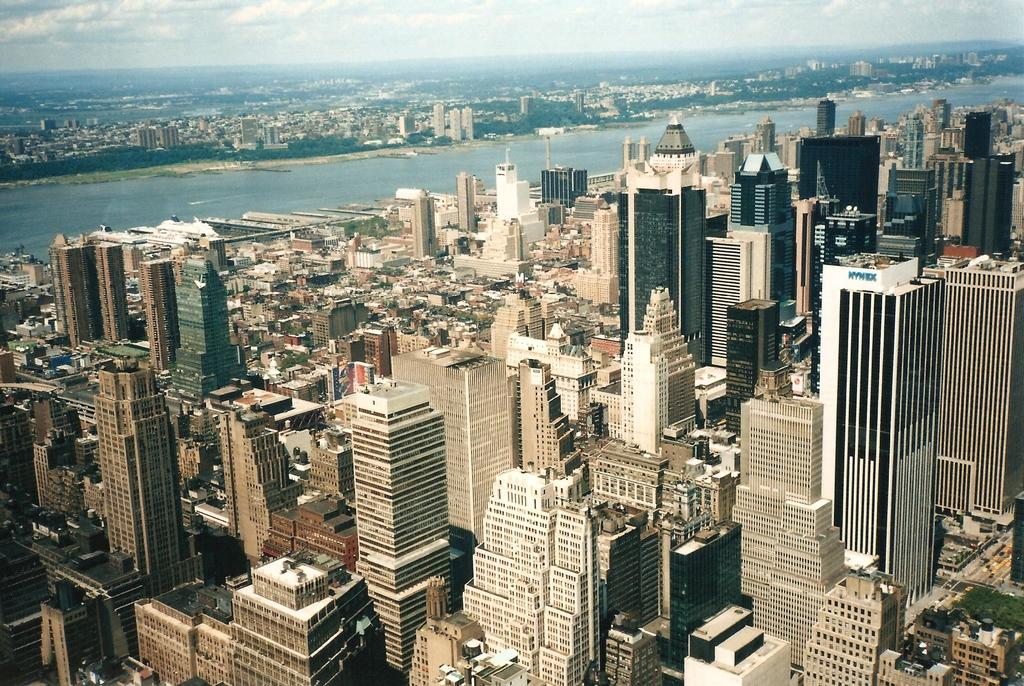What type of view is shown in the image? The image is an aerial view. What structures can be seen in the image? There are buildings in the image. What type of transportation infrastructure is visible? There is a road in the image. What natural element is present in the image? There is water visible in the image. What type of vegetation can be seen in the image? There are trees in the image. What is visible in the background of the image? The sky is visible in the image, and clouds are present in the sky. What is the purpose of the fire in the image? There is no fire present in the image. How does the stream flow through the image? There is no stream present in the image. 